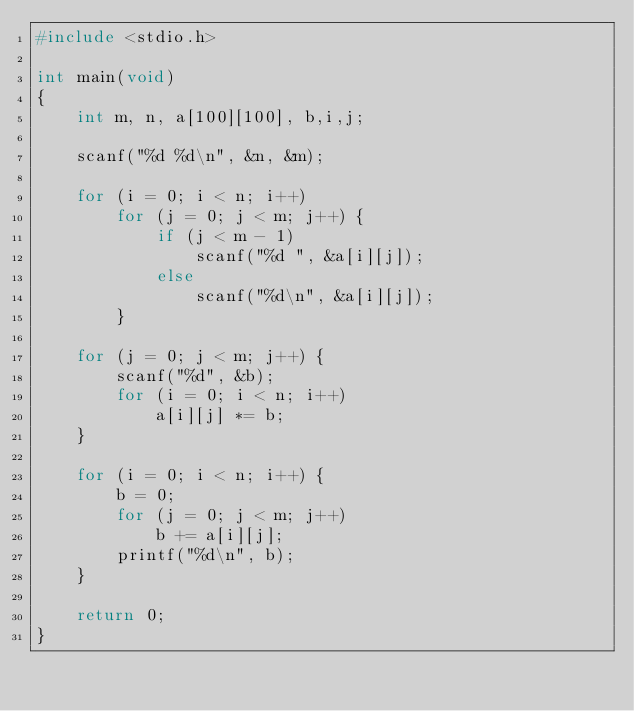Convert code to text. <code><loc_0><loc_0><loc_500><loc_500><_C_>#include <stdio.h>

int main(void)
{
	int m, n, a[100][100], b,i,j;

	scanf("%d %d\n", &n, &m);

	for (i = 0; i < n; i++)
		for (j = 0; j < m; j++) {
			if (j < m - 1)
				scanf("%d ", &a[i][j]);
			else
				scanf("%d\n", &a[i][j]);
		}

	for (j = 0; j < m; j++) {
		scanf("%d", &b);
		for (i = 0; i < n; i++)
			a[i][j] *= b;
	}

	for (i = 0; i < n; i++) {
		b = 0;
		for (j = 0; j < m; j++)
			b += a[i][j];
		printf("%d\n", b);
	}

	return 0;
}</code> 